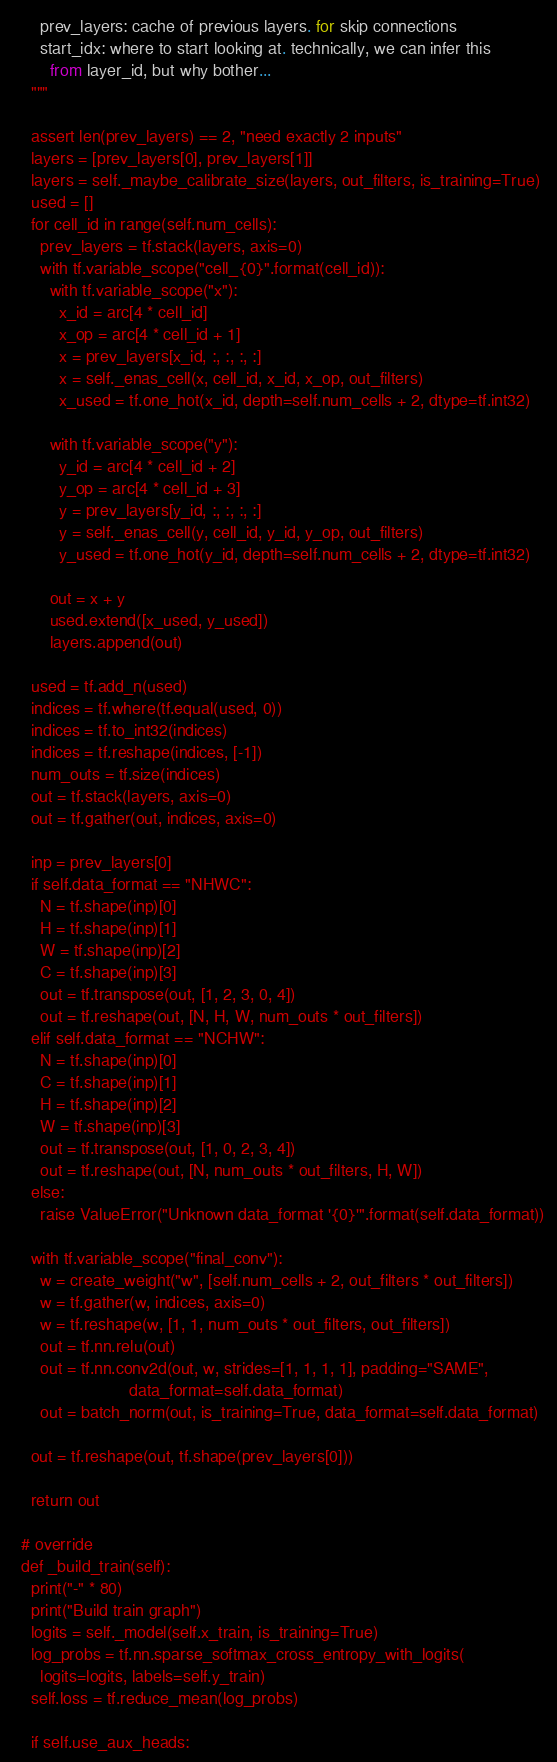<code> <loc_0><loc_0><loc_500><loc_500><_Python_>      prev_layers: cache of previous layers. for skip connections
      start_idx: where to start looking at. technically, we can infer this
        from layer_id, but why bother...
    """

    assert len(prev_layers) == 2, "need exactly 2 inputs"
    layers = [prev_layers[0], prev_layers[1]]
    layers = self._maybe_calibrate_size(layers, out_filters, is_training=True)
    used = []
    for cell_id in range(self.num_cells):
      prev_layers = tf.stack(layers, axis=0)
      with tf.variable_scope("cell_{0}".format(cell_id)):
        with tf.variable_scope("x"):
          x_id = arc[4 * cell_id]
          x_op = arc[4 * cell_id + 1]
          x = prev_layers[x_id, :, :, :, :]
          x = self._enas_cell(x, cell_id, x_id, x_op, out_filters)
          x_used = tf.one_hot(x_id, depth=self.num_cells + 2, dtype=tf.int32)

        with tf.variable_scope("y"):
          y_id = arc[4 * cell_id + 2]
          y_op = arc[4 * cell_id + 3]
          y = prev_layers[y_id, :, :, :, :]
          y = self._enas_cell(y, cell_id, y_id, y_op, out_filters)
          y_used = tf.one_hot(y_id, depth=self.num_cells + 2, dtype=tf.int32)

        out = x + y
        used.extend([x_used, y_used])
        layers.append(out)

    used = tf.add_n(used)
    indices = tf.where(tf.equal(used, 0))
    indices = tf.to_int32(indices)
    indices = tf.reshape(indices, [-1])
    num_outs = tf.size(indices)
    out = tf.stack(layers, axis=0)
    out = tf.gather(out, indices, axis=0)

    inp = prev_layers[0]
    if self.data_format == "NHWC":
      N = tf.shape(inp)[0]
      H = tf.shape(inp)[1]
      W = tf.shape(inp)[2]
      C = tf.shape(inp)[3]
      out = tf.transpose(out, [1, 2, 3, 0, 4])
      out = tf.reshape(out, [N, H, W, num_outs * out_filters])
    elif self.data_format == "NCHW":
      N = tf.shape(inp)[0]
      C = tf.shape(inp)[1]
      H = tf.shape(inp)[2]
      W = tf.shape(inp)[3]
      out = tf.transpose(out, [1, 0, 2, 3, 4])
      out = tf.reshape(out, [N, num_outs * out_filters, H, W])
    else:
      raise ValueError("Unknown data_format '{0}'".format(self.data_format))

    with tf.variable_scope("final_conv"):
      w = create_weight("w", [self.num_cells + 2, out_filters * out_filters])
      w = tf.gather(w, indices, axis=0)
      w = tf.reshape(w, [1, 1, num_outs * out_filters, out_filters])
      out = tf.nn.relu(out)
      out = tf.nn.conv2d(out, w, strides=[1, 1, 1, 1], padding="SAME",
                         data_format=self.data_format)
      out = batch_norm(out, is_training=True, data_format=self.data_format)

    out = tf.reshape(out, tf.shape(prev_layers[0]))

    return out

  # override
  def _build_train(self):
    print("-" * 80)
    print("Build train graph")
    logits = self._model(self.x_train, is_training=True)
    log_probs = tf.nn.sparse_softmax_cross_entropy_with_logits(
      logits=logits, labels=self.y_train)
    self.loss = tf.reduce_mean(log_probs)

    if self.use_aux_heads:</code> 